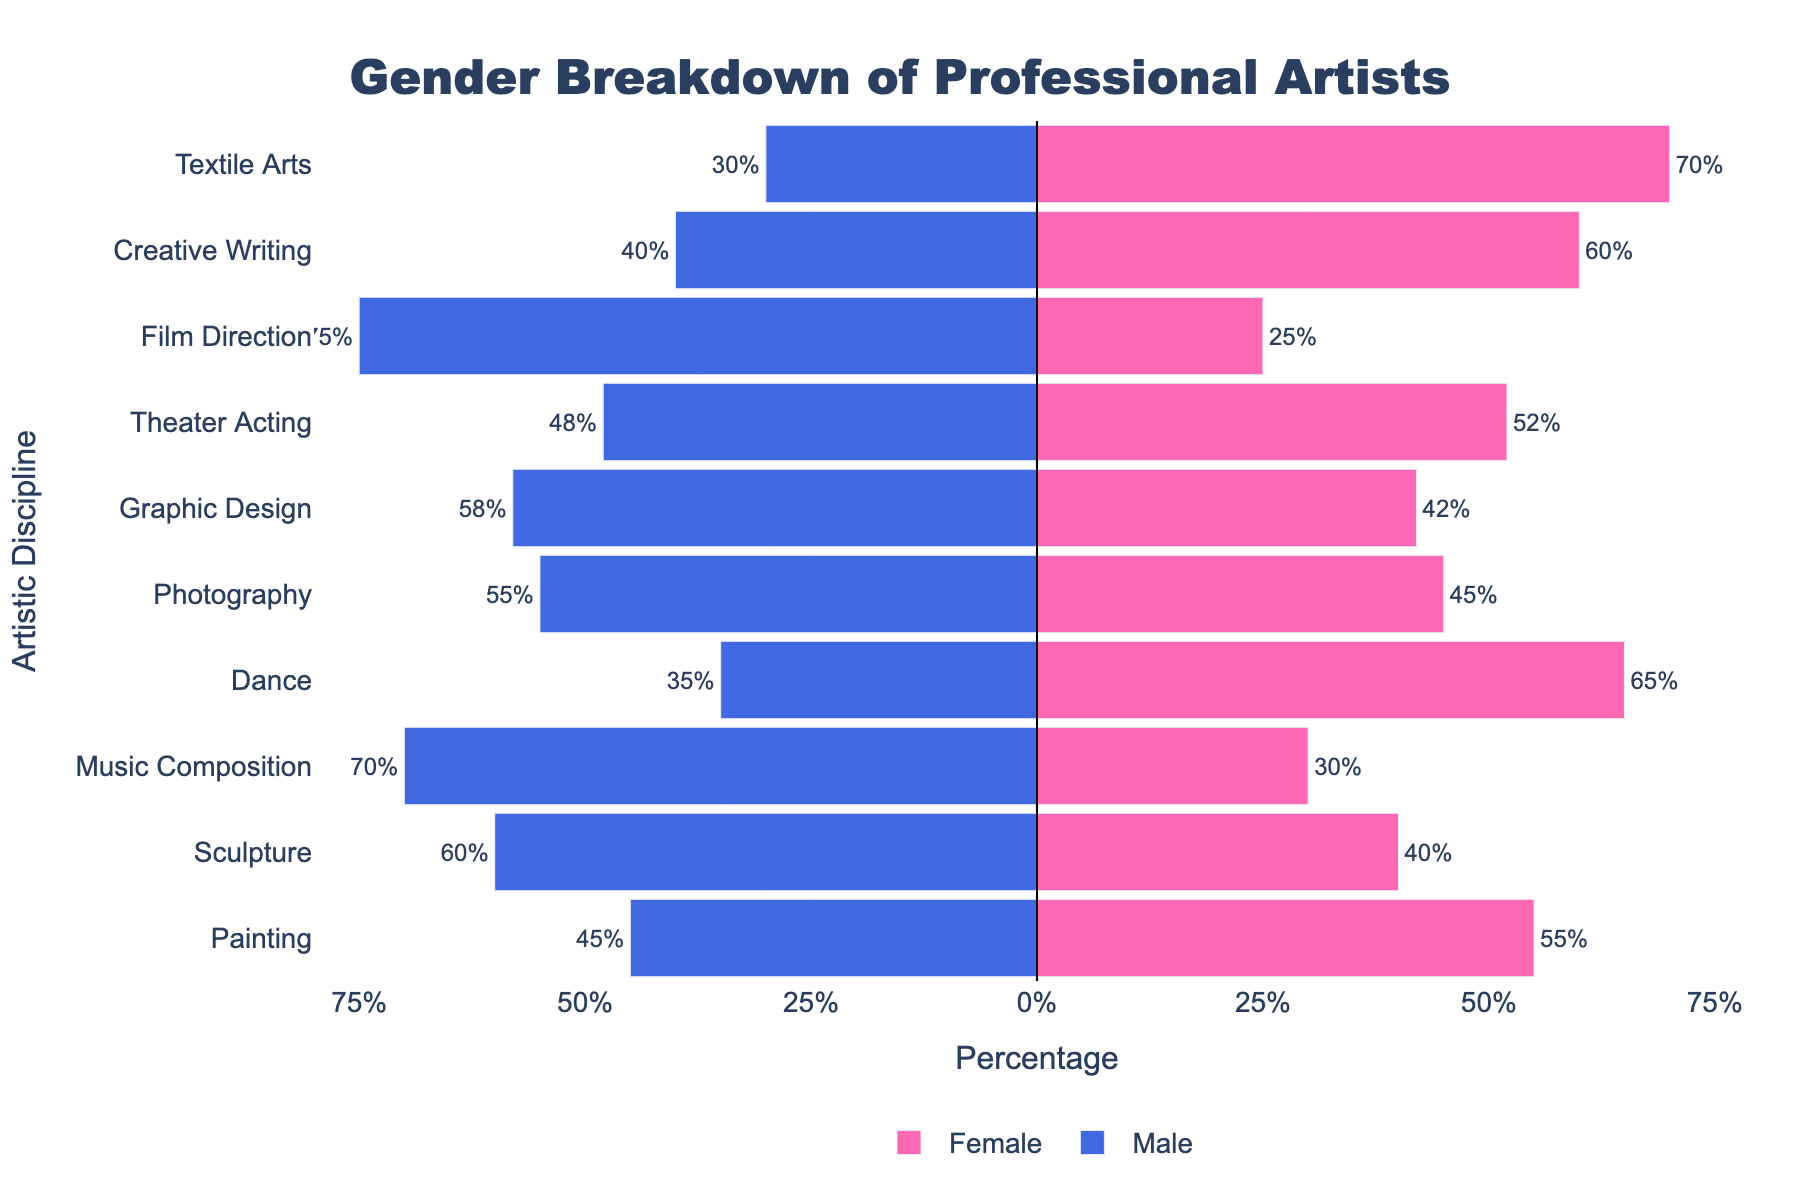what is the title of the chart? The title of the chart is text displayed prominently at the top of the figure. In this case, it reads "Gender Breakdown of Professional Artists".
Answer: Gender Breakdown of Professional Artists What is the percentage of male film directors? Look at the bar labeled 'Film Direction' on the left side of the pyramid. The bar extends to -75%, indicating that 75% of film directors are male.
Answer: 75% Which artistic discipline has the highest percentage of females? Observe the bars on the right side of the pyramid and identify the longest bar. The longest bar represents 'Textile Arts' with 70% females.
Answer: Textile Arts Which discipline shows a more balanced gender ratio? A more balanced gender ratio means the bars for males and females are closer in length. The discipline where this occurs is 'Theater Acting' with 48% males and 52% females.
Answer: Theater Acting Compare the percentage of female artists in Painting and Photography. Which one is higher? Examine the bars for 'Painting' and 'Photography' on the right side of the pyramid. 'Painting' has a bar extending to 55% and 'Photography' to 45%, making 'Painting' the discipline with a higher percentage of female artists.
Answer: Painting What is the combined percentage of female musicians and dancers? Add the percentages of females in 'Music Composition' and 'Dance'. 'Music Composition' has 30% and 'Dance' has 65%. The combined percentage is 30 + 65 = 95%.
Answer: 95% How many disciplines have a higher percentage of males than females? Count the number of disciplines where the bar on the left side (male) is longer than the bar on the right side (female). These disciplines are 'Sculpture', 'Music Composition', 'Photography', 'Graphic Design', and 'Film Direction', making a total of 5 disciplines.
Answer: 5 Which gender is predominant in Creative Writing? Look at the bars for 'Creative Writing'. The bar on the right (females) extends to 60%, which is longer than the bar on the left (males), indicating females are predominant.
Answer: Female Compare the percentages of males in Sculpture and Graphic Design. Which discipline has a higher percentage? Observe the bars for 'Sculpture' and 'Graphic Design' on the left side. 'Sculpture' has a bar extending to -60% and 'Graphic Design' extends to -58%, so 'Sculpture' has a higher percentage of males than 'Graphic Design'.
Answer: Sculpture What is the percentage difference between male and female Textile Artists? Calculate the absolute difference between males and females in 'Textile Arts'. The percentages are 30% males and 70% females. The difference is 70 - 30 = 40%.
Answer: 40% 